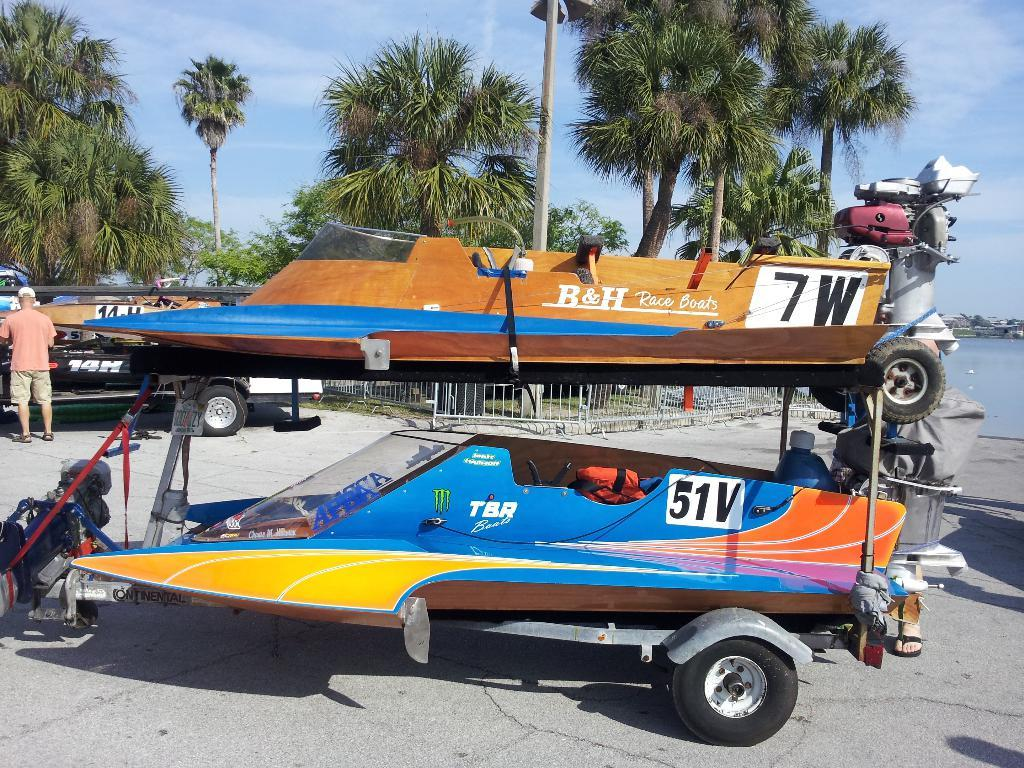<image>
Give a short and clear explanation of the subsequent image. A pair of water toys, one of which is tagged 7W and one is which is tagged 51V. 